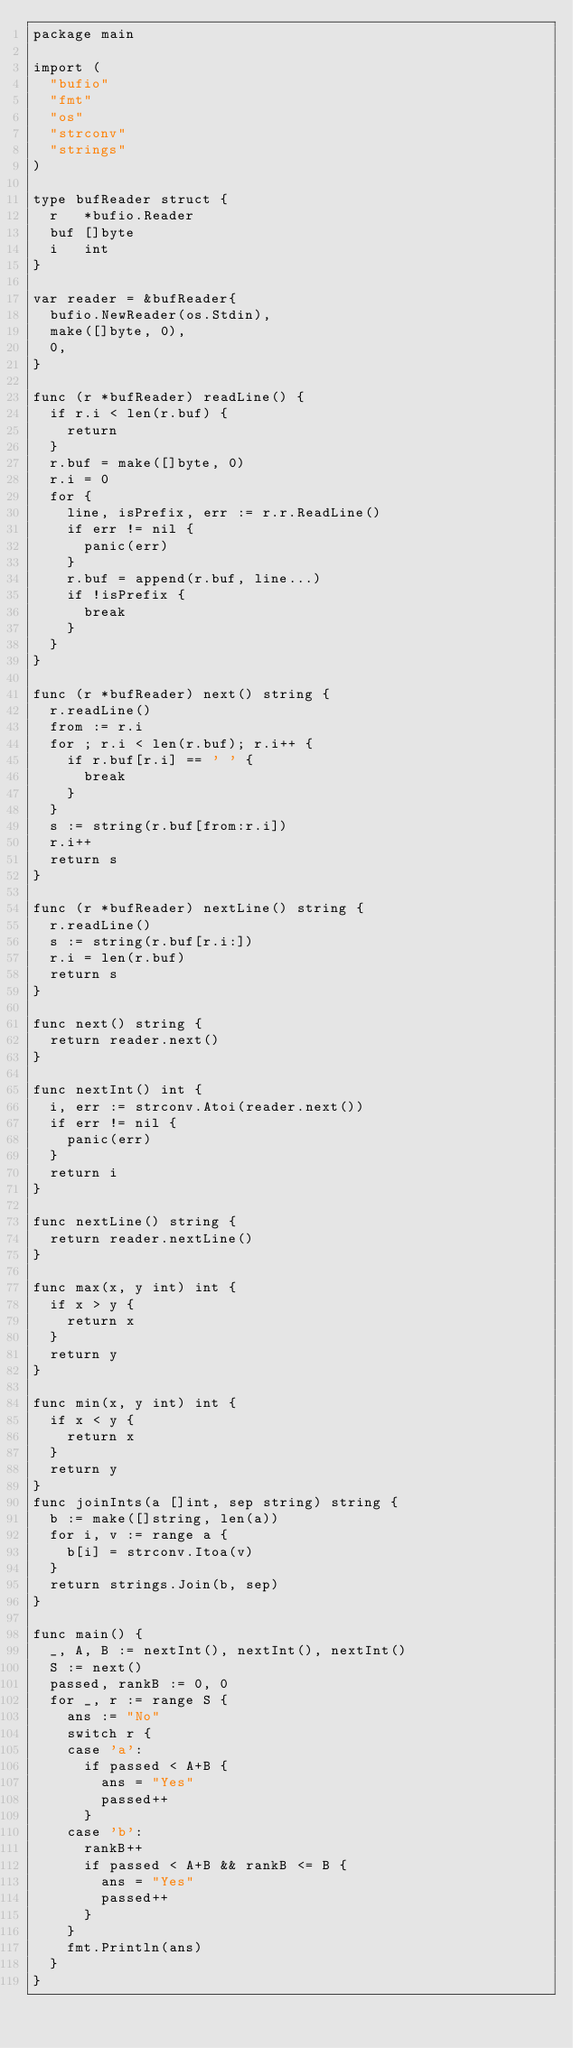Convert code to text. <code><loc_0><loc_0><loc_500><loc_500><_Go_>package main

import (
	"bufio"
	"fmt"
	"os"
	"strconv"
	"strings"
)

type bufReader struct {
	r   *bufio.Reader
	buf []byte
	i   int
}

var reader = &bufReader{
	bufio.NewReader(os.Stdin),
	make([]byte, 0),
	0,
}

func (r *bufReader) readLine() {
	if r.i < len(r.buf) {
		return
	}
	r.buf = make([]byte, 0)
	r.i = 0
	for {
		line, isPrefix, err := r.r.ReadLine()
		if err != nil {
			panic(err)
		}
		r.buf = append(r.buf, line...)
		if !isPrefix {
			break
		}
	}
}

func (r *bufReader) next() string {
	r.readLine()
	from := r.i
	for ; r.i < len(r.buf); r.i++ {
		if r.buf[r.i] == ' ' {
			break
		}
	}
	s := string(r.buf[from:r.i])
	r.i++
	return s
}

func (r *bufReader) nextLine() string {
	r.readLine()
	s := string(r.buf[r.i:])
	r.i = len(r.buf)
	return s
}

func next() string {
	return reader.next()
}

func nextInt() int {
	i, err := strconv.Atoi(reader.next())
	if err != nil {
		panic(err)
	}
	return i
}

func nextLine() string {
	return reader.nextLine()
}

func max(x, y int) int {
	if x > y {
		return x
	}
	return y
}

func min(x, y int) int {
	if x < y {
		return x
	}
	return y
}
func joinInts(a []int, sep string) string {
	b := make([]string, len(a))
	for i, v := range a {
		b[i] = strconv.Itoa(v)
	}
	return strings.Join(b, sep)
}

func main() {
	_, A, B := nextInt(), nextInt(), nextInt()
	S := next()
	passed, rankB := 0, 0
	for _, r := range S {
		ans := "No"
		switch r {
		case 'a':
			if passed < A+B {
				ans = "Yes"
				passed++
			}
		case 'b':
			rankB++
			if passed < A+B && rankB <= B {
				ans = "Yes"
				passed++
			}
		}
		fmt.Println(ans)
	}
}
</code> 